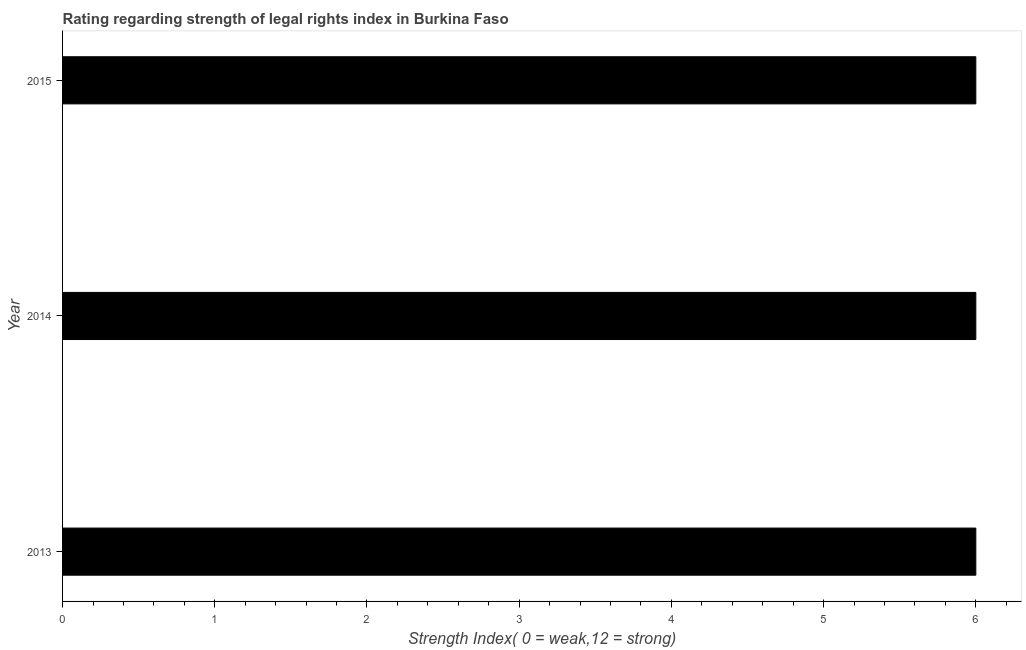What is the title of the graph?
Make the answer very short. Rating regarding strength of legal rights index in Burkina Faso. What is the label or title of the X-axis?
Offer a terse response. Strength Index( 0 = weak,12 = strong). What is the label or title of the Y-axis?
Ensure brevity in your answer.  Year. What is the strength of legal rights index in 2015?
Your answer should be compact. 6. Across all years, what is the minimum strength of legal rights index?
Keep it short and to the point. 6. What is the sum of the strength of legal rights index?
Ensure brevity in your answer.  18. What is the difference between the strength of legal rights index in 2013 and 2014?
Offer a terse response. 0. What is the median strength of legal rights index?
Your response must be concise. 6. In how many years, is the strength of legal rights index greater than 4.8 ?
Your answer should be compact. 3. Is the strength of legal rights index in 2014 less than that in 2015?
Your answer should be very brief. No. What is the difference between the highest and the second highest strength of legal rights index?
Provide a short and direct response. 0. How many bars are there?
Keep it short and to the point. 3. How many years are there in the graph?
Ensure brevity in your answer.  3. What is the difference between two consecutive major ticks on the X-axis?
Your answer should be very brief. 1. What is the Strength Index( 0 = weak,12 = strong) in 2013?
Offer a terse response. 6. What is the Strength Index( 0 = weak,12 = strong) of 2014?
Give a very brief answer. 6. What is the difference between the Strength Index( 0 = weak,12 = strong) in 2013 and 2015?
Your answer should be very brief. 0. What is the ratio of the Strength Index( 0 = weak,12 = strong) in 2013 to that in 2014?
Your response must be concise. 1. What is the ratio of the Strength Index( 0 = weak,12 = strong) in 2013 to that in 2015?
Give a very brief answer. 1. 